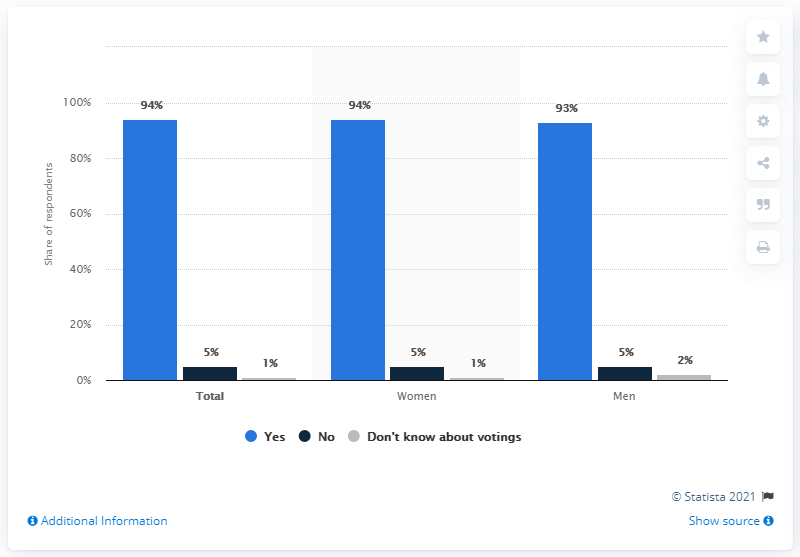Draw attention to some important aspects in this diagram. The opinion with the highest score in all categories is Yes. 5% of respondents stated that they will not be voting in the upcoming general election. The percentage difference between men and women is 2. 